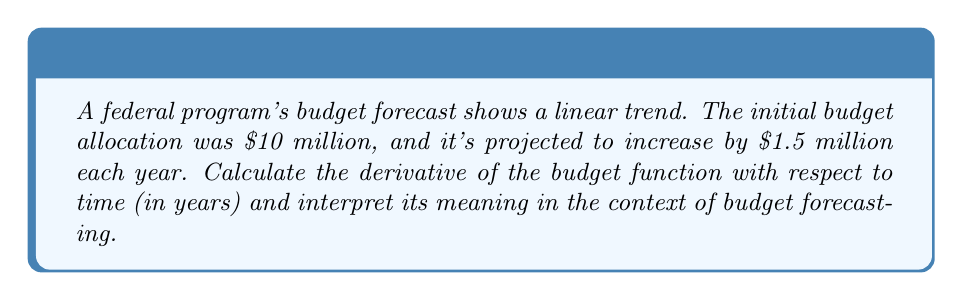Solve this math problem. Let's approach this step-by-step:

1) First, we need to express the budget as a function of time. Let $B(t)$ be the budget in millions of dollars after $t$ years.

2) Given the initial budget and yearly increase, we can write the function as:

   $B(t) = 10 + 1.5t$

3) To find the derivative, we need to differentiate $B(t)$ with respect to $t$:

   $$\frac{d}{dt}B(t) = \frac{d}{dt}(10 + 1.5t)$$

4) The derivative of a constant (10) is 0, and the derivative of $1.5t$ is 1.5:

   $$\frac{d}{dt}B(t) = 0 + 1.5 = 1.5$$

5) Interpretation: The derivative $\frac{dB}{dt} = 1.5$ represents the rate of change of the budget with respect to time. In this context, it means the budget is increasing at a constant rate of $1.5 million per year.

6) In terms of slope, the derivative gives us the slope of the budget trend line. A positive slope of 1.5 indicates an upward trend in the budget over time.

7) For auditing and financial compliance, this information is crucial. It helps in understanding the pace of budget growth, planning for future allocations, and ensuring that the growth rate aligns with program goals and federal guidelines.
Answer: $\frac{dB}{dt} = 1.5$ million dollars per year 